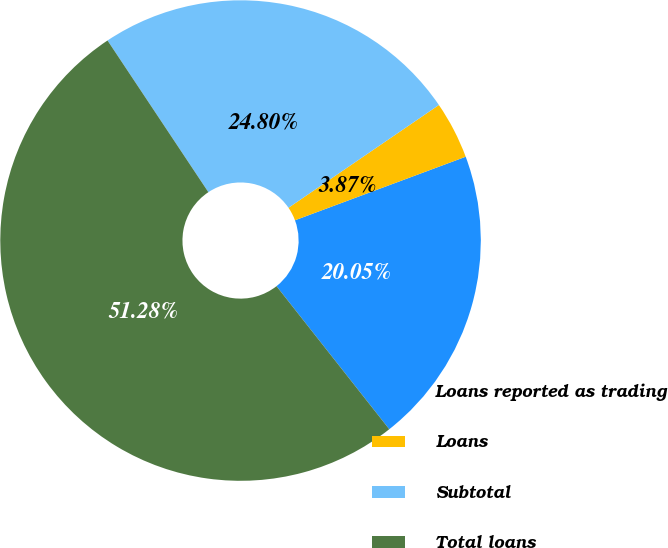Convert chart. <chart><loc_0><loc_0><loc_500><loc_500><pie_chart><fcel>Loans reported as trading<fcel>Loans<fcel>Subtotal<fcel>Total loans<nl><fcel>20.05%<fcel>3.87%<fcel>24.8%<fcel>51.29%<nl></chart> 